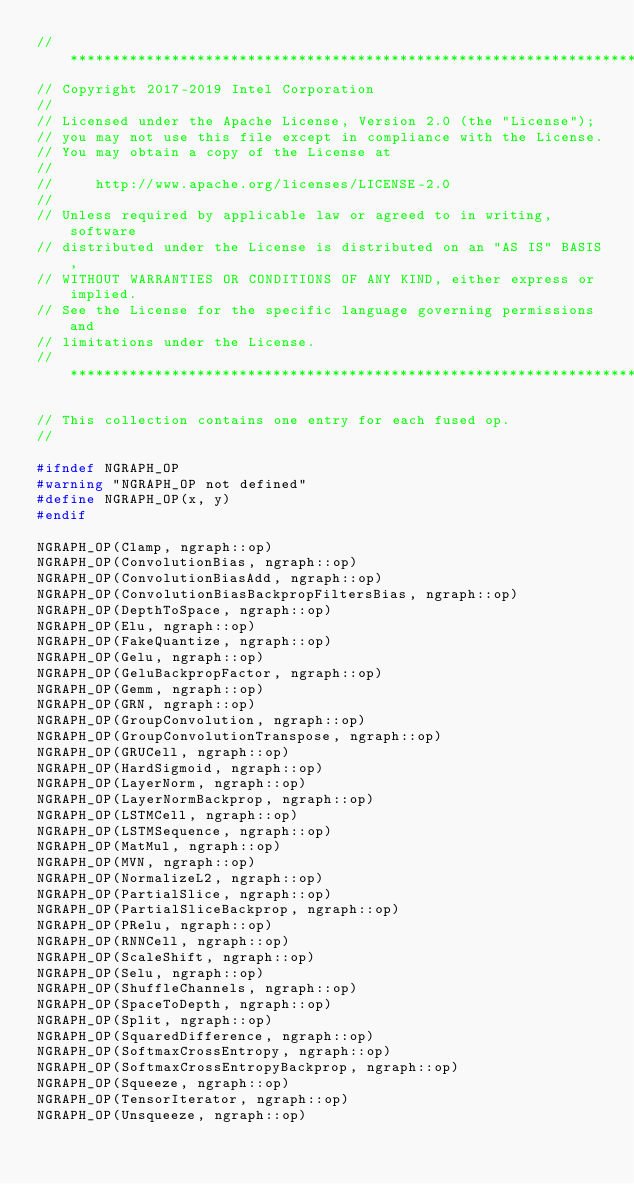<code> <loc_0><loc_0><loc_500><loc_500><_C++_>//*****************************************************************************
// Copyright 2017-2019 Intel Corporation
//
// Licensed under the Apache License, Version 2.0 (the "License");
// you may not use this file except in compliance with the License.
// You may obtain a copy of the License at
//
//     http://www.apache.org/licenses/LICENSE-2.0
//
// Unless required by applicable law or agreed to in writing, software
// distributed under the License is distributed on an "AS IS" BASIS,
// WITHOUT WARRANTIES OR CONDITIONS OF ANY KIND, either express or implied.
// See the License for the specific language governing permissions and
// limitations under the License.
//*****************************************************************************

// This collection contains one entry for each fused op.
//

#ifndef NGRAPH_OP
#warning "NGRAPH_OP not defined"
#define NGRAPH_OP(x, y)
#endif

NGRAPH_OP(Clamp, ngraph::op)
NGRAPH_OP(ConvolutionBias, ngraph::op)
NGRAPH_OP(ConvolutionBiasAdd, ngraph::op)
NGRAPH_OP(ConvolutionBiasBackpropFiltersBias, ngraph::op)
NGRAPH_OP(DepthToSpace, ngraph::op)
NGRAPH_OP(Elu, ngraph::op)
NGRAPH_OP(FakeQuantize, ngraph::op)
NGRAPH_OP(Gelu, ngraph::op)
NGRAPH_OP(GeluBackpropFactor, ngraph::op)
NGRAPH_OP(Gemm, ngraph::op)
NGRAPH_OP(GRN, ngraph::op)
NGRAPH_OP(GroupConvolution, ngraph::op)
NGRAPH_OP(GroupConvolutionTranspose, ngraph::op)
NGRAPH_OP(GRUCell, ngraph::op)
NGRAPH_OP(HardSigmoid, ngraph::op)
NGRAPH_OP(LayerNorm, ngraph::op)
NGRAPH_OP(LayerNormBackprop, ngraph::op)
NGRAPH_OP(LSTMCell, ngraph::op)
NGRAPH_OP(LSTMSequence, ngraph::op)
NGRAPH_OP(MatMul, ngraph::op)
NGRAPH_OP(MVN, ngraph::op)
NGRAPH_OP(NormalizeL2, ngraph::op)
NGRAPH_OP(PartialSlice, ngraph::op)
NGRAPH_OP(PartialSliceBackprop, ngraph::op)
NGRAPH_OP(PRelu, ngraph::op)
NGRAPH_OP(RNNCell, ngraph::op)
NGRAPH_OP(ScaleShift, ngraph::op)
NGRAPH_OP(Selu, ngraph::op)
NGRAPH_OP(ShuffleChannels, ngraph::op)
NGRAPH_OP(SpaceToDepth, ngraph::op)
NGRAPH_OP(Split, ngraph::op)
NGRAPH_OP(SquaredDifference, ngraph::op)
NGRAPH_OP(SoftmaxCrossEntropy, ngraph::op)
NGRAPH_OP(SoftmaxCrossEntropyBackprop, ngraph::op)
NGRAPH_OP(Squeeze, ngraph::op)
NGRAPH_OP(TensorIterator, ngraph::op)
NGRAPH_OP(Unsqueeze, ngraph::op)
</code> 